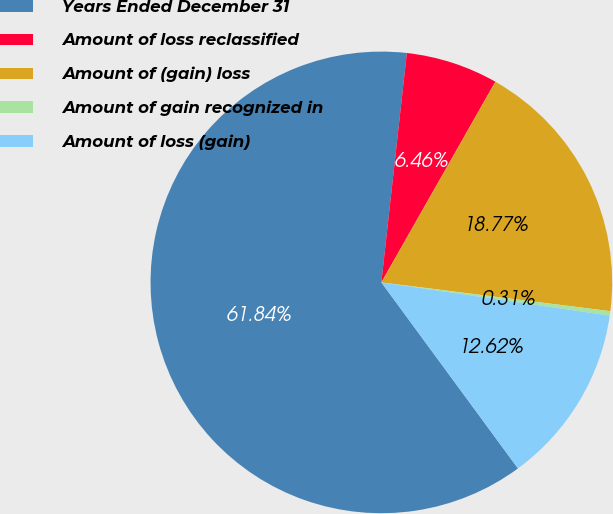Convert chart to OTSL. <chart><loc_0><loc_0><loc_500><loc_500><pie_chart><fcel>Years Ended December 31<fcel>Amount of loss reclassified<fcel>Amount of (gain) loss<fcel>Amount of gain recognized in<fcel>Amount of loss (gain)<nl><fcel>61.85%<fcel>6.46%<fcel>18.77%<fcel>0.31%<fcel>12.62%<nl></chart> 